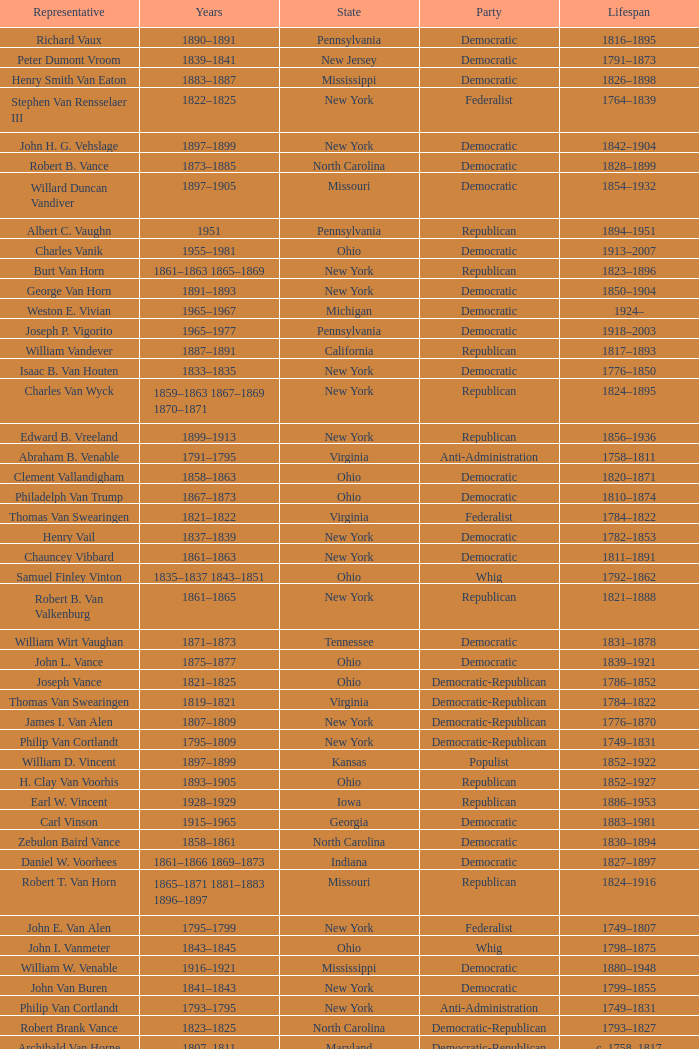What is the lifespan of Joseph Vance, a democratic-republican from Ohio? 1786–1852. 